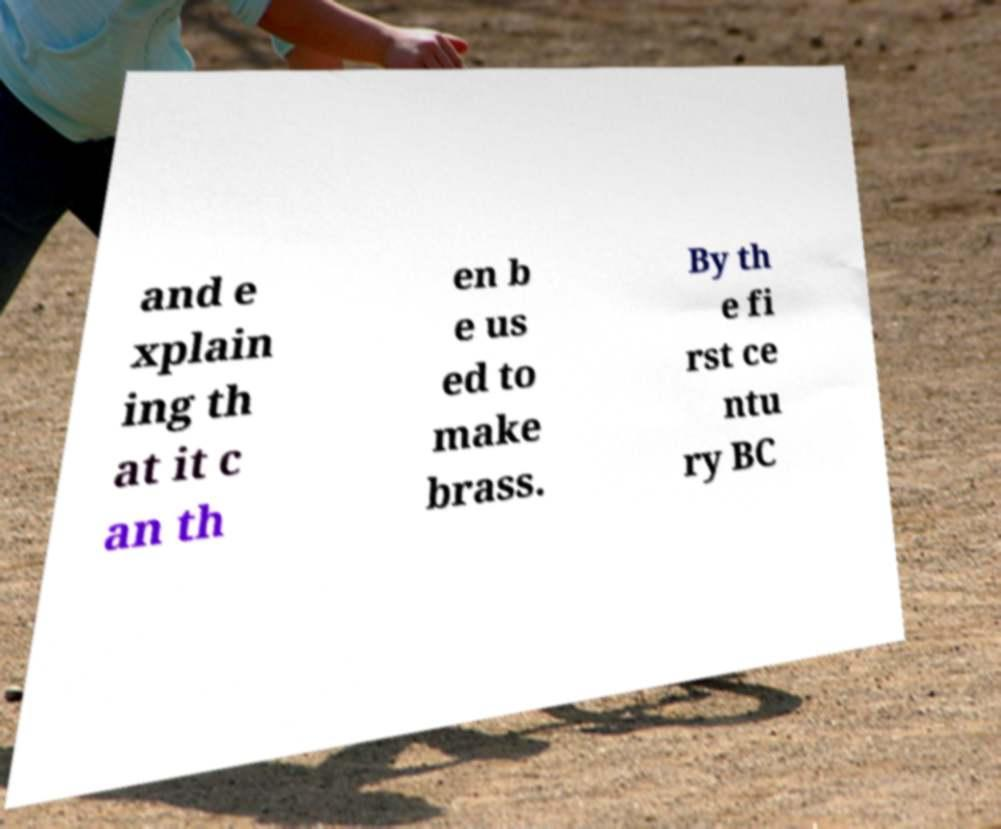There's text embedded in this image that I need extracted. Can you transcribe it verbatim? and e xplain ing th at it c an th en b e us ed to make brass. By th e fi rst ce ntu ry BC 